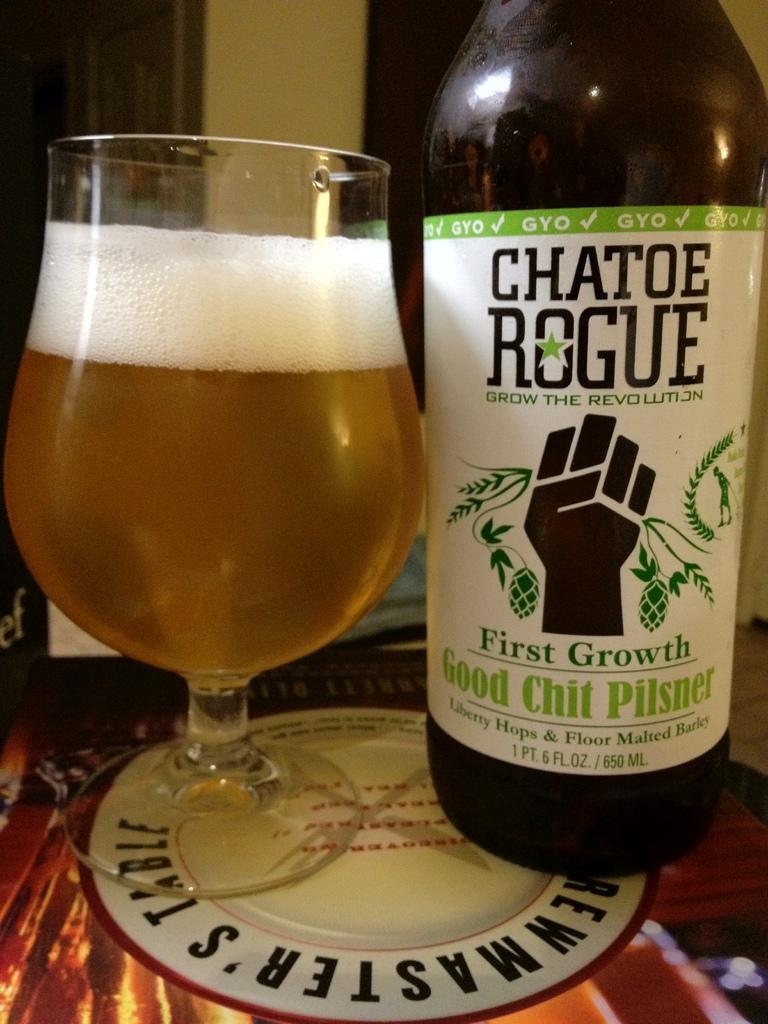<image>
Write a terse but informative summary of the picture. Chatoe Rogue is a maker of a good pilsner beer. 